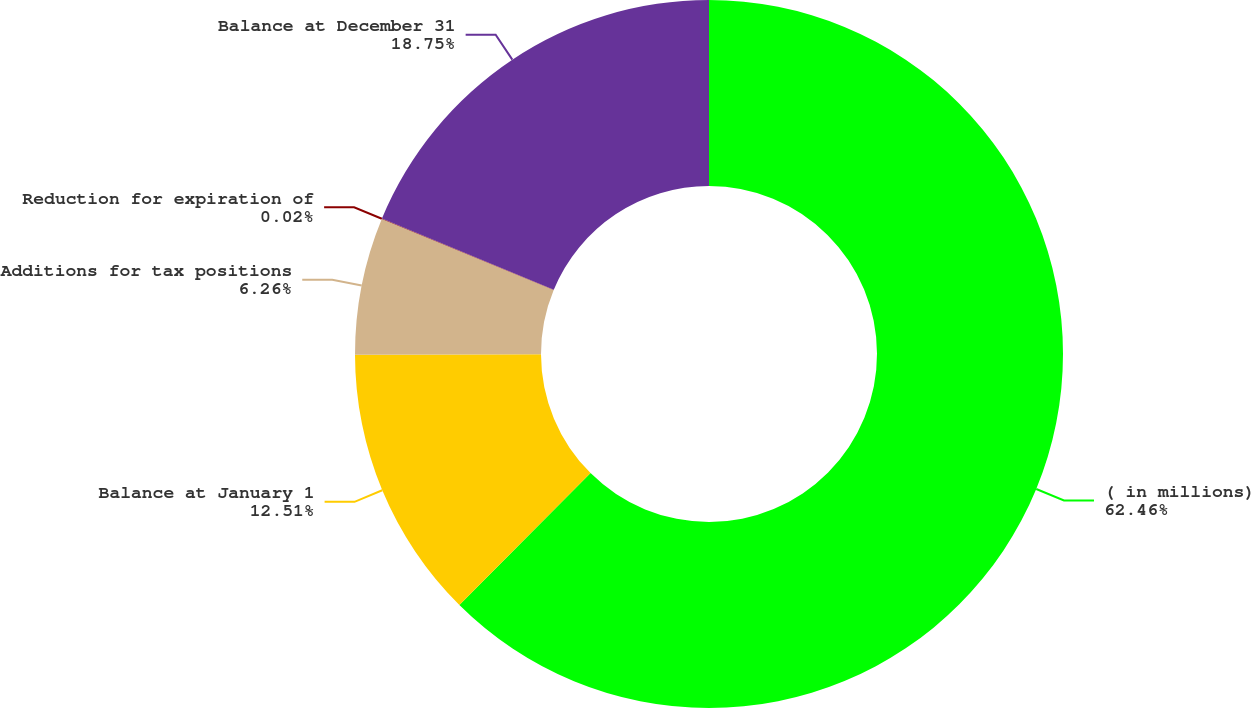Convert chart to OTSL. <chart><loc_0><loc_0><loc_500><loc_500><pie_chart><fcel>( in millions)<fcel>Balance at January 1<fcel>Additions for tax positions<fcel>Reduction for expiration of<fcel>Balance at December 31<nl><fcel>62.45%<fcel>12.51%<fcel>6.26%<fcel>0.02%<fcel>18.75%<nl></chart> 